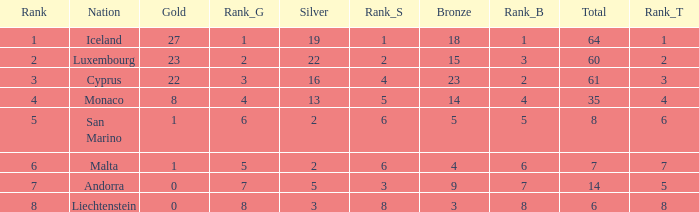How many bronzes for nations with over 22 golds and ranked under 2? 18.0. 